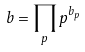Convert formula to latex. <formula><loc_0><loc_0><loc_500><loc_500>b = \prod _ { p } p ^ { b _ { p } }</formula> 